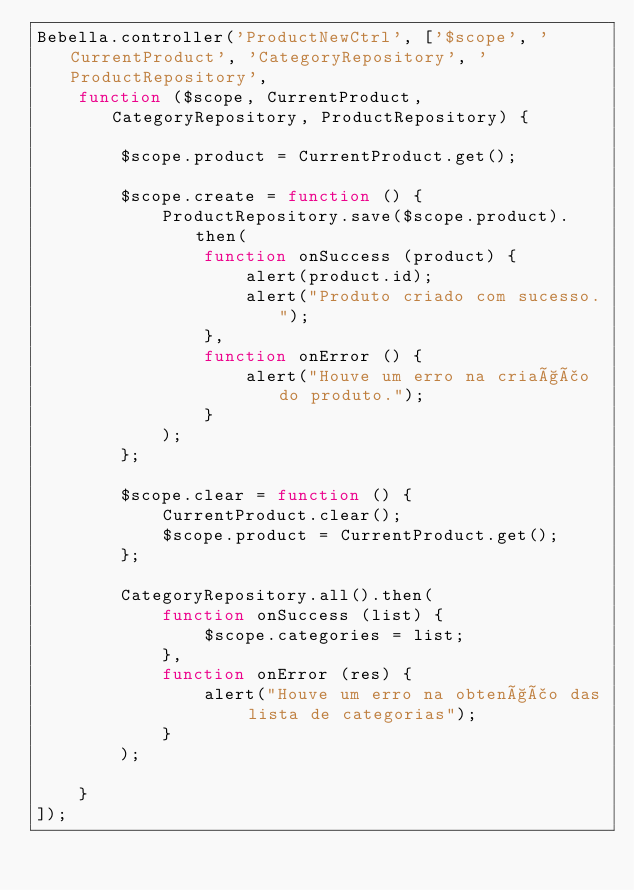Convert code to text. <code><loc_0><loc_0><loc_500><loc_500><_JavaScript_>Bebella.controller('ProductNewCtrl', ['$scope', 'CurrentProduct', 'CategoryRepository', 'ProductRepository',
    function ($scope, CurrentProduct, CategoryRepository, ProductRepository) {
        
        $scope.product = CurrentProduct.get();
        
        $scope.create = function () {
            ProductRepository.save($scope.product).then(
                function onSuccess (product) {
                    alert(product.id);
                    alert("Produto criado com sucesso.");
                },
                function onError () {
                    alert("Houve um erro na criação do produto.");
                }
            );
        };
        
        $scope.clear = function () {
            CurrentProduct.clear();
            $scope.product = CurrentProduct.get();
        };
        
        CategoryRepository.all().then(
            function onSuccess (list) {
                $scope.categories = list;
            },
            function onError (res) {
                alert("Houve um erro na obtenção das lista de categorias");
            }
        );
        
    }
]);

</code> 